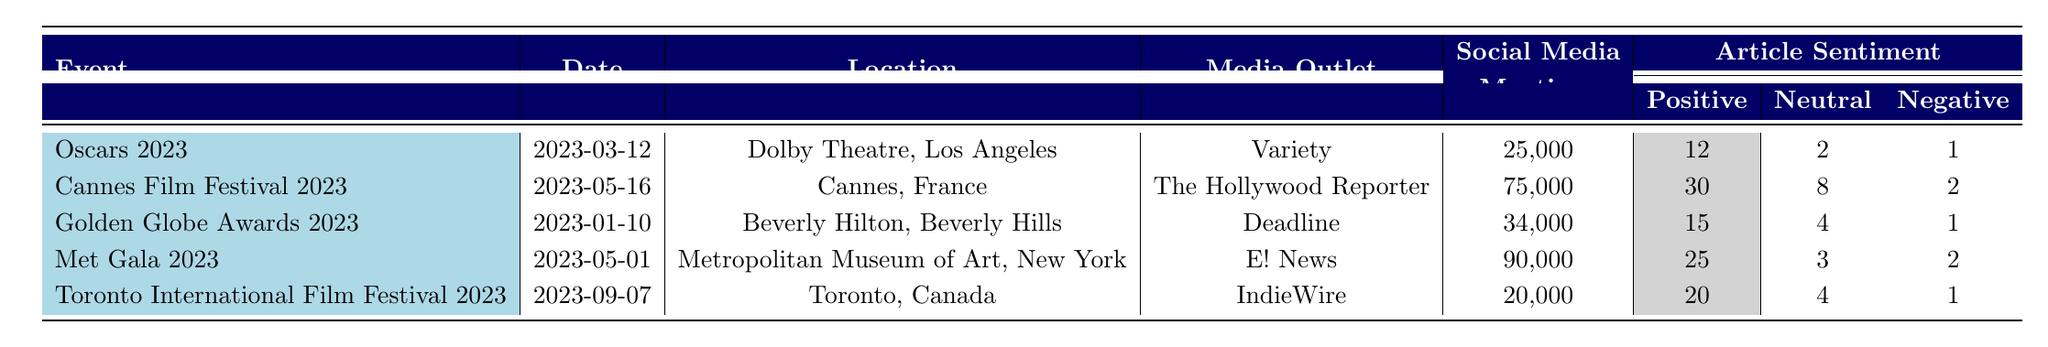What event had the highest number of articles published? The event with the highest number of articles published is the Cannes Film Festival 2023 with 40 articles.
Answer: Cannes Film Festival 2023 How many positive articles were published for the Golden Globe Awards 2023? For the Golden Globe Awards 2023, there were 15 positive articles published.
Answer: 15 Which event had the lowest social media mentions? The event with the lowest social media mentions is the Toronto International Film Festival 2023, with 20,000 mentions.
Answer: Toronto International Film Festival 2023 What is the total number of negative articles across all events? Adding the negative articles for each event: 1 (Oscars) + 2 (Cannes) + 1 (Golden Globe) + 2 (Met Gala) + 1 (Toronto) gives a total of 7 negative articles.
Answer: 7 Which event had the highest ratio of positive to negative articles? To find the ratio for each event, divide the number of positive articles by the number of negative articles: Oscars (12/1=12), Cannes (30/2=15), Golden Globes (15/1=15), Met Gala (25/2=12.5), Toronto (20/1=20). The highest ratio is for the Toronto International Film Festival at 20.
Answer: Toronto International Film Festival 2023 Did the Met Gala 2023 receive more social media mentions than the Oscars 2023? The Met Gala 2023 received 90,000 social media mentions while the Oscars 2023 received 25,000 mentions, so the Met Gala had more mentions.
Answer: Yes What is the average number of social media mentions across all listed events? The total number of social media mentions is 25,000 + 75,000 + 34,000 + 90,000 + 20,000 = 244,000. There are 5 events, so the average is 244,000 / 5 = 48,800.
Answer: 48,800 Which media outlet published the least number of articles? The outlet that published the least number of articles is the Oscars 2023 with 15 articles published.
Answer: Oscars 2023 What is the sentiment distribution for the Cannes Film Festival 2023? The sentiment distribution for Cannes is 30 positive articles, 8 neutral articles, and 2 negative articles.
Answer: 30 positive, 8 neutral, 2 negative How do the total social media mentions for the Met Gala 2023 compare to the Cannes Film Festival 2023? The Met Gala 2023 had 90,000 mentions while the Cannes Film Festival 2023 had 75,000 mentions, meaning the Met Gala had more.
Answer: Met Gala 2023 had more social media mentions 